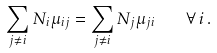Convert formula to latex. <formula><loc_0><loc_0><loc_500><loc_500>\sum _ { j \ne i } N _ { i } \mu _ { i j } = \sum _ { j \ne i } N _ { j } \mu _ { j i } \quad \forall \, i \, .</formula> 